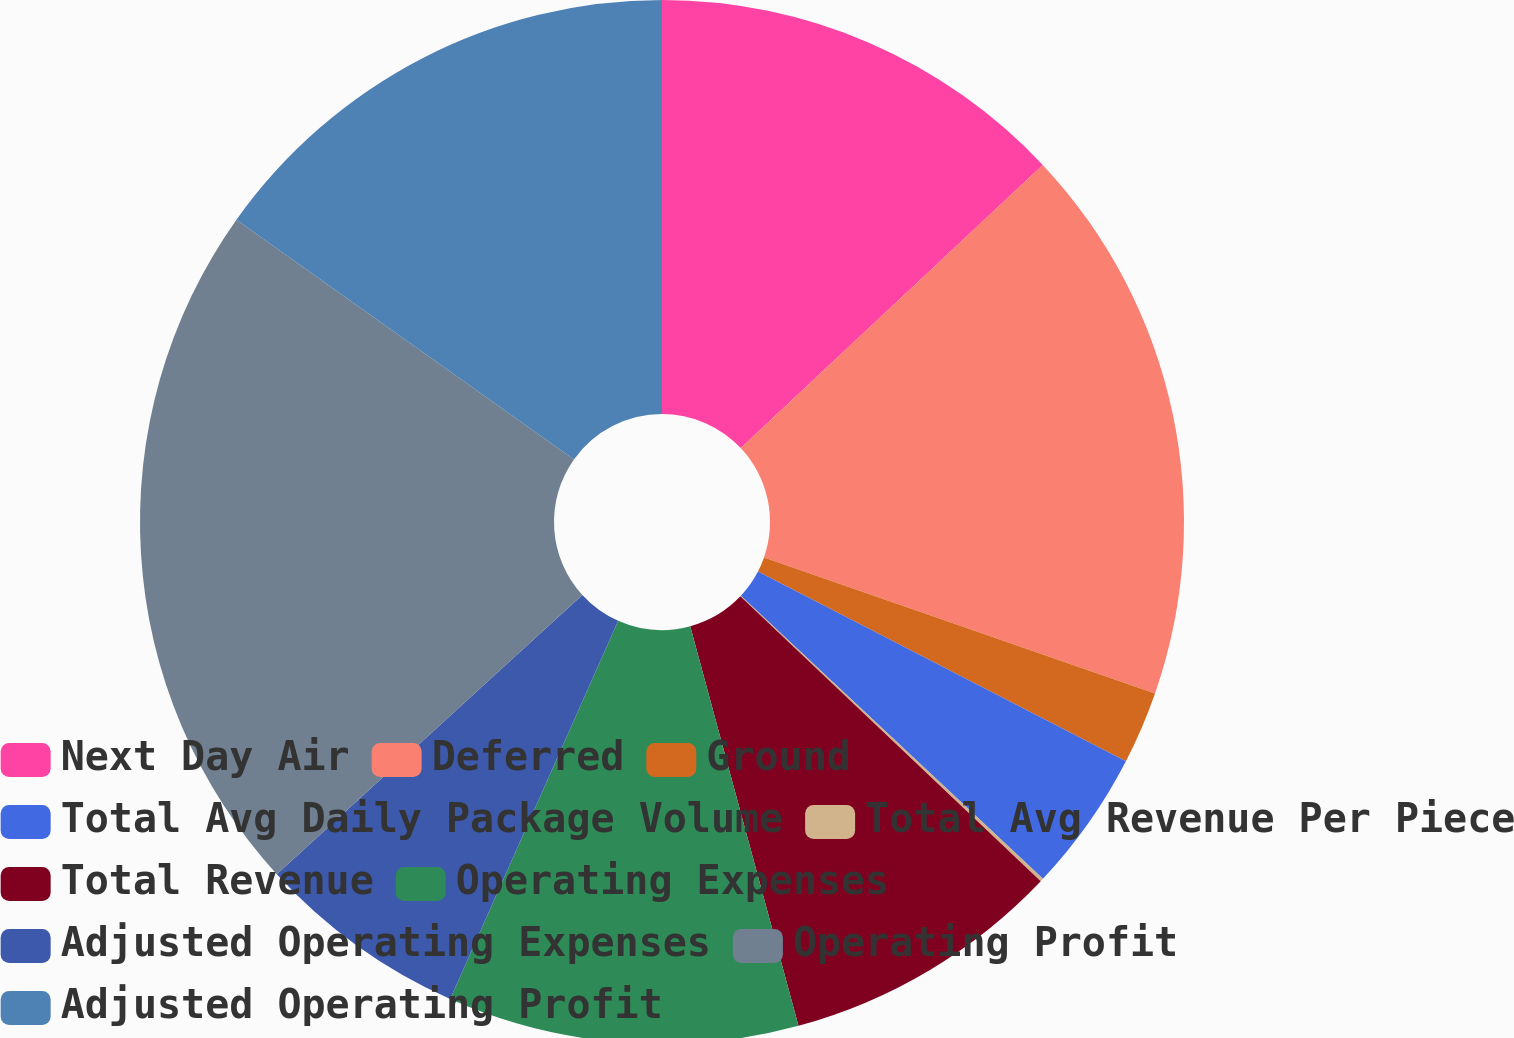<chart> <loc_0><loc_0><loc_500><loc_500><pie_chart><fcel>Next Day Air<fcel>Deferred<fcel>Ground<fcel>Total Avg Daily Package Volume<fcel>Total Avg Revenue Per Piece<fcel>Total Revenue<fcel>Operating Expenses<fcel>Adjusted Operating Expenses<fcel>Operating Profit<fcel>Adjusted Operating Profit<nl><fcel>13.01%<fcel>17.32%<fcel>2.25%<fcel>4.4%<fcel>0.1%<fcel>8.71%<fcel>10.86%<fcel>6.56%<fcel>21.62%<fcel>15.17%<nl></chart> 